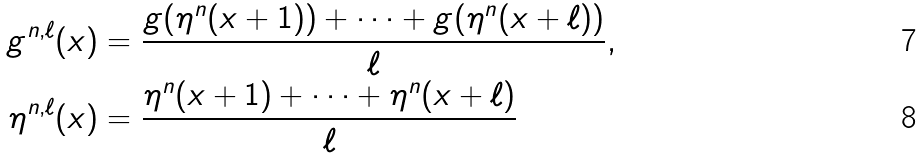Convert formula to latex. <formula><loc_0><loc_0><loc_500><loc_500>g ^ { n , \ell } ( x ) & = \frac { g ( \eta ^ { n } ( x + 1 ) ) + \cdots + g ( \eta ^ { n } ( x + \ell ) ) } { \ell } , \\ \eta ^ { n , \ell } ( x ) & = \frac { \eta ^ { n } ( x + 1 ) + \cdots + \eta ^ { n } ( x + \ell ) } { \ell }</formula> 